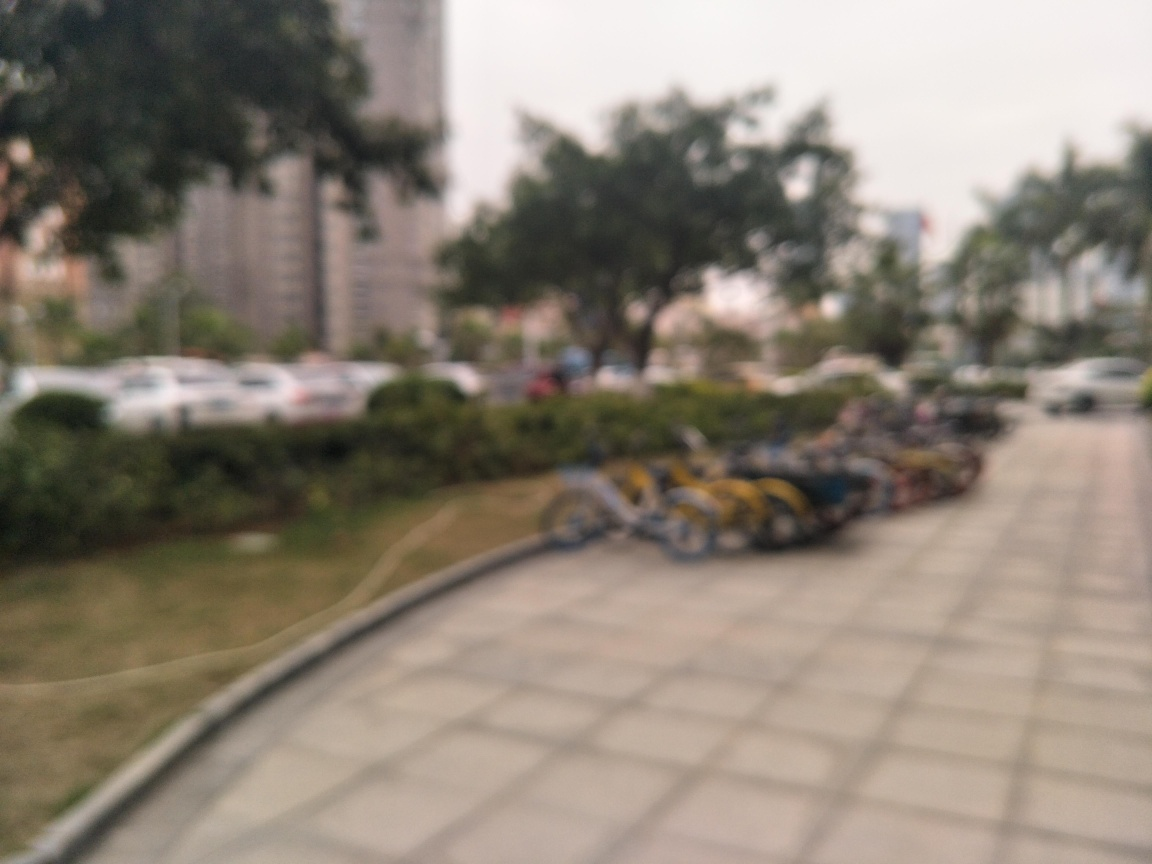Is the background blurred? Yes, the background of the image is blurred, which draws attention to the foreground, though in this case, the entire image appears to have a shallow depth of field, causing everything to lose detail. 